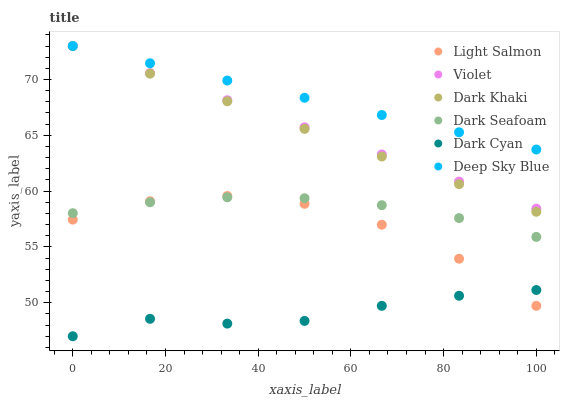Does Dark Cyan have the minimum area under the curve?
Answer yes or no. Yes. Does Deep Sky Blue have the maximum area under the curve?
Answer yes or no. Yes. Does Dark Khaki have the minimum area under the curve?
Answer yes or no. No. Does Dark Khaki have the maximum area under the curve?
Answer yes or no. No. Is Dark Khaki the smoothest?
Answer yes or no. Yes. Is Light Salmon the roughest?
Answer yes or no. Yes. Is Dark Seafoam the smoothest?
Answer yes or no. No. Is Dark Seafoam the roughest?
Answer yes or no. No. Does Dark Cyan have the lowest value?
Answer yes or no. Yes. Does Dark Khaki have the lowest value?
Answer yes or no. No. Does Violet have the highest value?
Answer yes or no. Yes. Does Dark Seafoam have the highest value?
Answer yes or no. No. Is Dark Cyan less than Violet?
Answer yes or no. Yes. Is Deep Sky Blue greater than Light Salmon?
Answer yes or no. Yes. Does Deep Sky Blue intersect Violet?
Answer yes or no. Yes. Is Deep Sky Blue less than Violet?
Answer yes or no. No. Is Deep Sky Blue greater than Violet?
Answer yes or no. No. Does Dark Cyan intersect Violet?
Answer yes or no. No. 